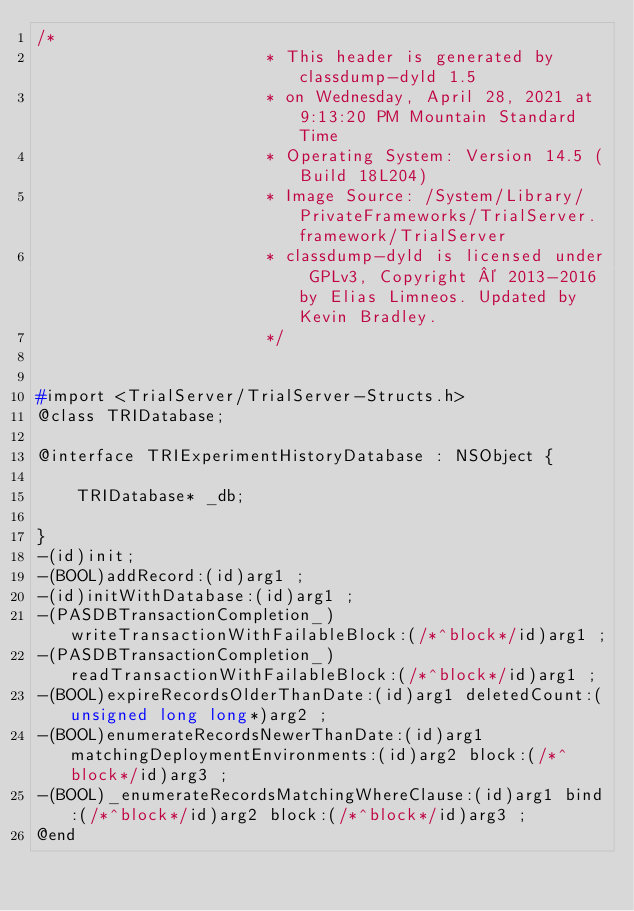<code> <loc_0><loc_0><loc_500><loc_500><_C_>/*
                       * This header is generated by classdump-dyld 1.5
                       * on Wednesday, April 28, 2021 at 9:13:20 PM Mountain Standard Time
                       * Operating System: Version 14.5 (Build 18L204)
                       * Image Source: /System/Library/PrivateFrameworks/TrialServer.framework/TrialServer
                       * classdump-dyld is licensed under GPLv3, Copyright © 2013-2016 by Elias Limneos. Updated by Kevin Bradley.
                       */


#import <TrialServer/TrialServer-Structs.h>
@class TRIDatabase;

@interface TRIExperimentHistoryDatabase : NSObject {

	TRIDatabase* _db;

}
-(id)init;
-(BOOL)addRecord:(id)arg1 ;
-(id)initWithDatabase:(id)arg1 ;
-(PASDBTransactionCompletion_)writeTransactionWithFailableBlock:(/*^block*/id)arg1 ;
-(PASDBTransactionCompletion_)readTransactionWithFailableBlock:(/*^block*/id)arg1 ;
-(BOOL)expireRecordsOlderThanDate:(id)arg1 deletedCount:(unsigned long long*)arg2 ;
-(BOOL)enumerateRecordsNewerThanDate:(id)arg1 matchingDeploymentEnvironments:(id)arg2 block:(/*^block*/id)arg3 ;
-(BOOL)_enumerateRecordsMatchingWhereClause:(id)arg1 bind:(/*^block*/id)arg2 block:(/*^block*/id)arg3 ;
@end

</code> 